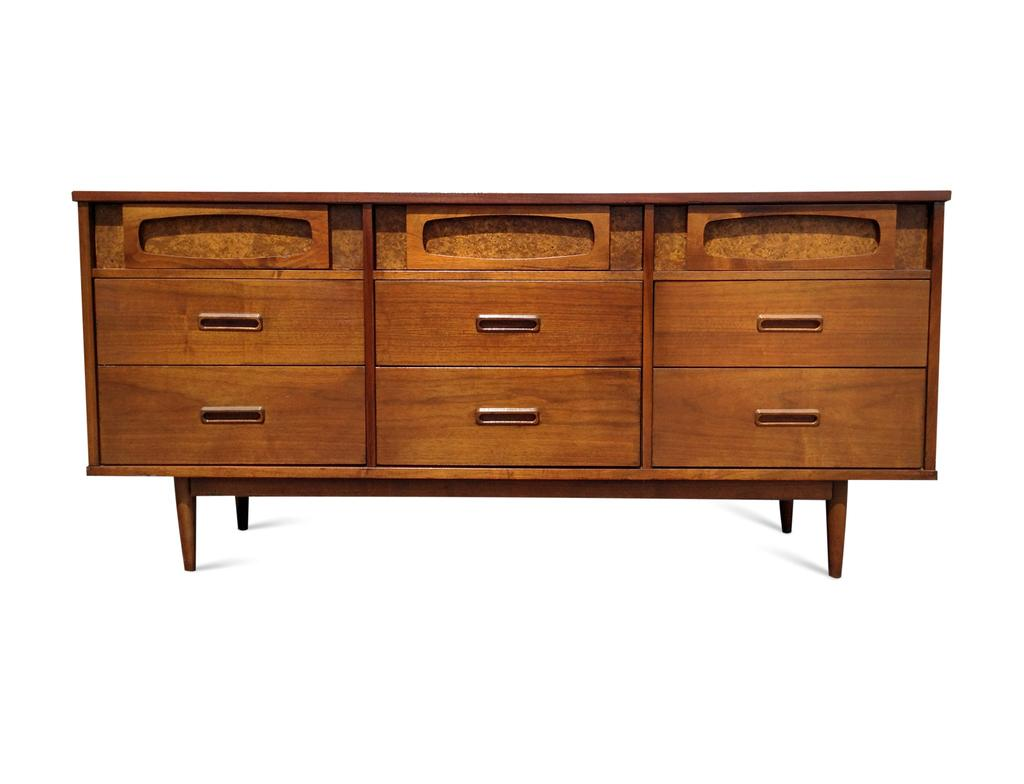What type of furniture is present in the image? There is a cupboard in the image. How is the cupboard emphasized in the image? The cupboard is highlighted in the image. What color is the cupboard? The cupboard is in brown color. What type of statement is written on the cupboard in the image? There is no statement written on the cupboard in the image. What type of yarn is used to decorate the cupboard in the image? There is no yarn used to decorate the cupboard in the image. 